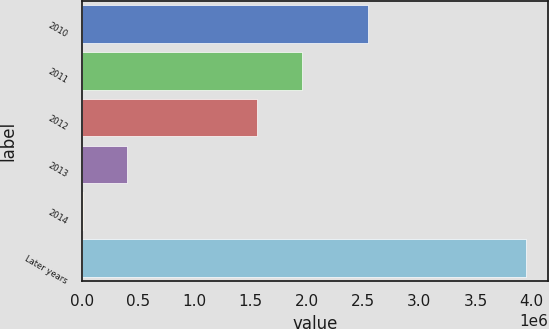Convert chart. <chart><loc_0><loc_0><loc_500><loc_500><bar_chart><fcel>2010<fcel>2011<fcel>2012<fcel>2013<fcel>2014<fcel>Later years<nl><fcel>2.53982e+06<fcel>1.95436e+06<fcel>1.56019e+06<fcel>401278<fcel>7113<fcel>3.94876e+06<nl></chart> 